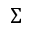<formula> <loc_0><loc_0><loc_500><loc_500>\Sigma</formula> 